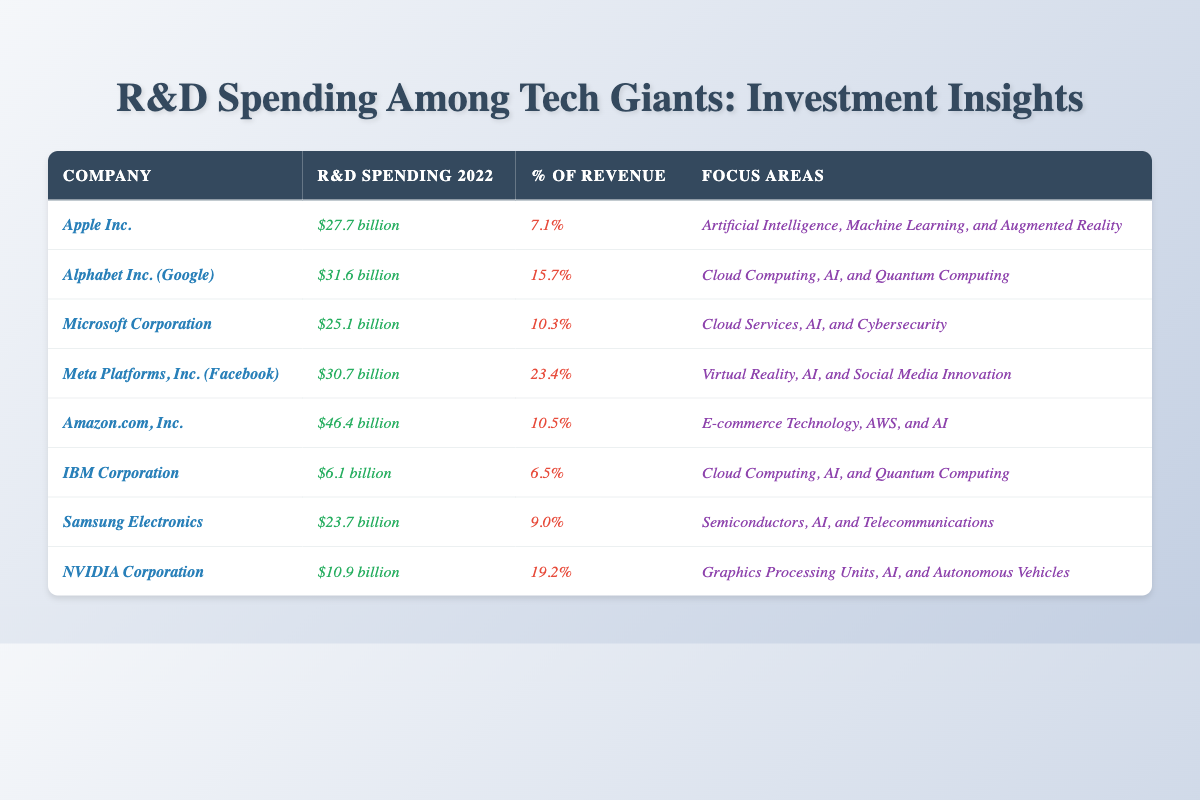What is the R&D spending of Amazon.com, Inc.? According to the table, Amazon.com, Inc. has an R&D spending of $46.4 billion in 2022.
Answer: $46.4 billion Which company has the highest percentage of revenue spent on R&D? By reviewing the table, Meta Platforms, Inc. (Facebook) has the highest percentage of revenue spent on R&D at 23.4%.
Answer: 23.4% What is the total R&D spending of Apple Inc. and Microsoft Corporation combined? Adding the R&D spending of Apple Inc. ($27.7 billion) and Microsoft Corporation ($25.1 billion) gives a total of $52.8 billion.
Answer: $52.8 billion Is IBM Corporation's R&D spending greater than that of Samsung Electronics? The table shows that IBM Corporation has R&D spending of $6.1 billion while Samsung Electronics has $23.7 billion. Thus, IBM's spending is not greater.
Answer: No How much more does Alphabet Inc. spend on R&D than IBM Corporation? Alphabet Inc. has R&D spending of $31.6 billion and IBM Corporation has $6.1 billion. The difference is $31.6 billion - $6.1 billion = $25.5 billion.
Answer: $25.5 billion What percentage of revenue is spent on R&D by NVIDIA Corporation? According to the table, NVIDIA Corporation spends 19.2% of its revenue on R&D.
Answer: 19.2% If you average the R&D spending of all companies listed, what is the average? The total R&D spending is $27.7 + $31.6 + $25.1 + $30.7 + $46.4 + $6.1 + $23.7 + $10.9 = $201.2 billion. Dividing this by 8 gives an average of $25.15 billion.
Answer: $25.15 billion Which companies focus on Artificial Intelligence in their R&D? From the table, the companies that focus on Artificial Intelligence include Apple Inc., Alphabet Inc., Microsoft Corporation, Meta Platforms, Inc., Amazon.com, Inc., Samsung Electronics, and NVIDIA Corporation.
Answer: Seven companies Compare the focus areas of Amazon.com, Inc. and Meta Platforms, Inc. Amazon's focus areas are E-commerce Technology, AWS, and AI, while Meta focuses on Virtual Reality, AI, and Social Media Innovation. Both companies include AI, but their other areas differ significantly.
Answer: Different focus areas, common in AI Does Samsung Electronics spend more on R&D than Microsoft Corporation? The table indicates that Samsung Electronics has R&D spending of $23.7 billion while Microsoft Corporation has $25.1 billion, thus Samsung does not spend more.
Answer: No 